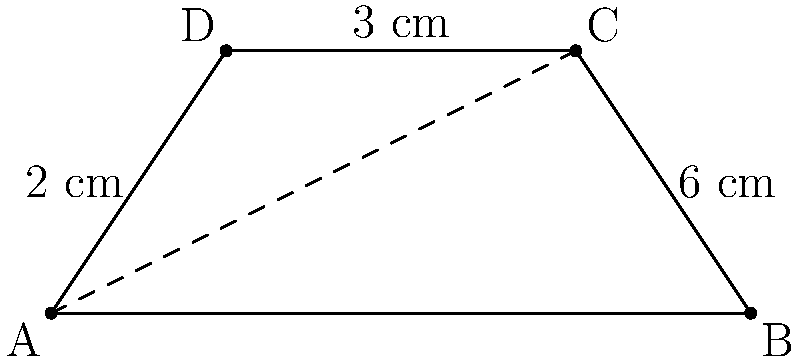In your classroom, you have a trapezoidal-shaped bulletin board. The bottom base measures 8 cm, the top base measures 6 cm, and the height is 3 cm. What is the area of this bulletin board in square centimeters? Let's approach this step-by-step:

1) The formula for the area of a trapezoid is:

   $$A = \frac{1}{2}(b_1 + b_2)h$$

   where $A$ is the area, $b_1$ and $b_2$ are the lengths of the parallel sides, and $h$ is the height.

2) In this case:
   $b_1 = 8$ cm (bottom base)
   $b_2 = 6$ cm (top base)
   $h = 3$ cm (height)

3) Let's substitute these values into the formula:

   $$A = \frac{1}{2}(8 + 6) \times 3$$

4) First, add the bases:
   
   $$A = \frac{1}{2}(14) \times 3$$

5) Multiply:
   
   $$A = 7 \times 3 = 21$$

Therefore, the area of the bulletin board is 21 square centimeters.
Answer: 21 cm² 